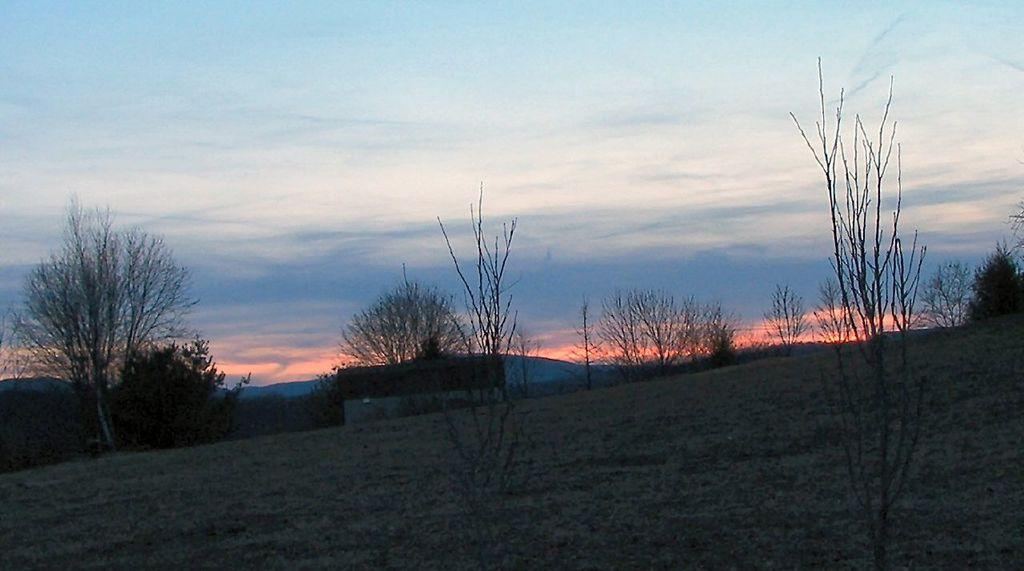Where was the image taken? The image is clicked outside. What type of ground is visible in the image? There is green grass on the ground. What can be seen in the middle of the image? There are plants and trees in the middle of the image. What is visible at the top of the image? The sky is visible at the top of the image. What type of patch is the father wearing on his shirt in the image? There is no father or shirt present in the image; it features plants, trees, and green grass. How many leaves are on the tree in the image? The image does not provide a specific count of leaves on the tree; it only shows the presence of trees. 